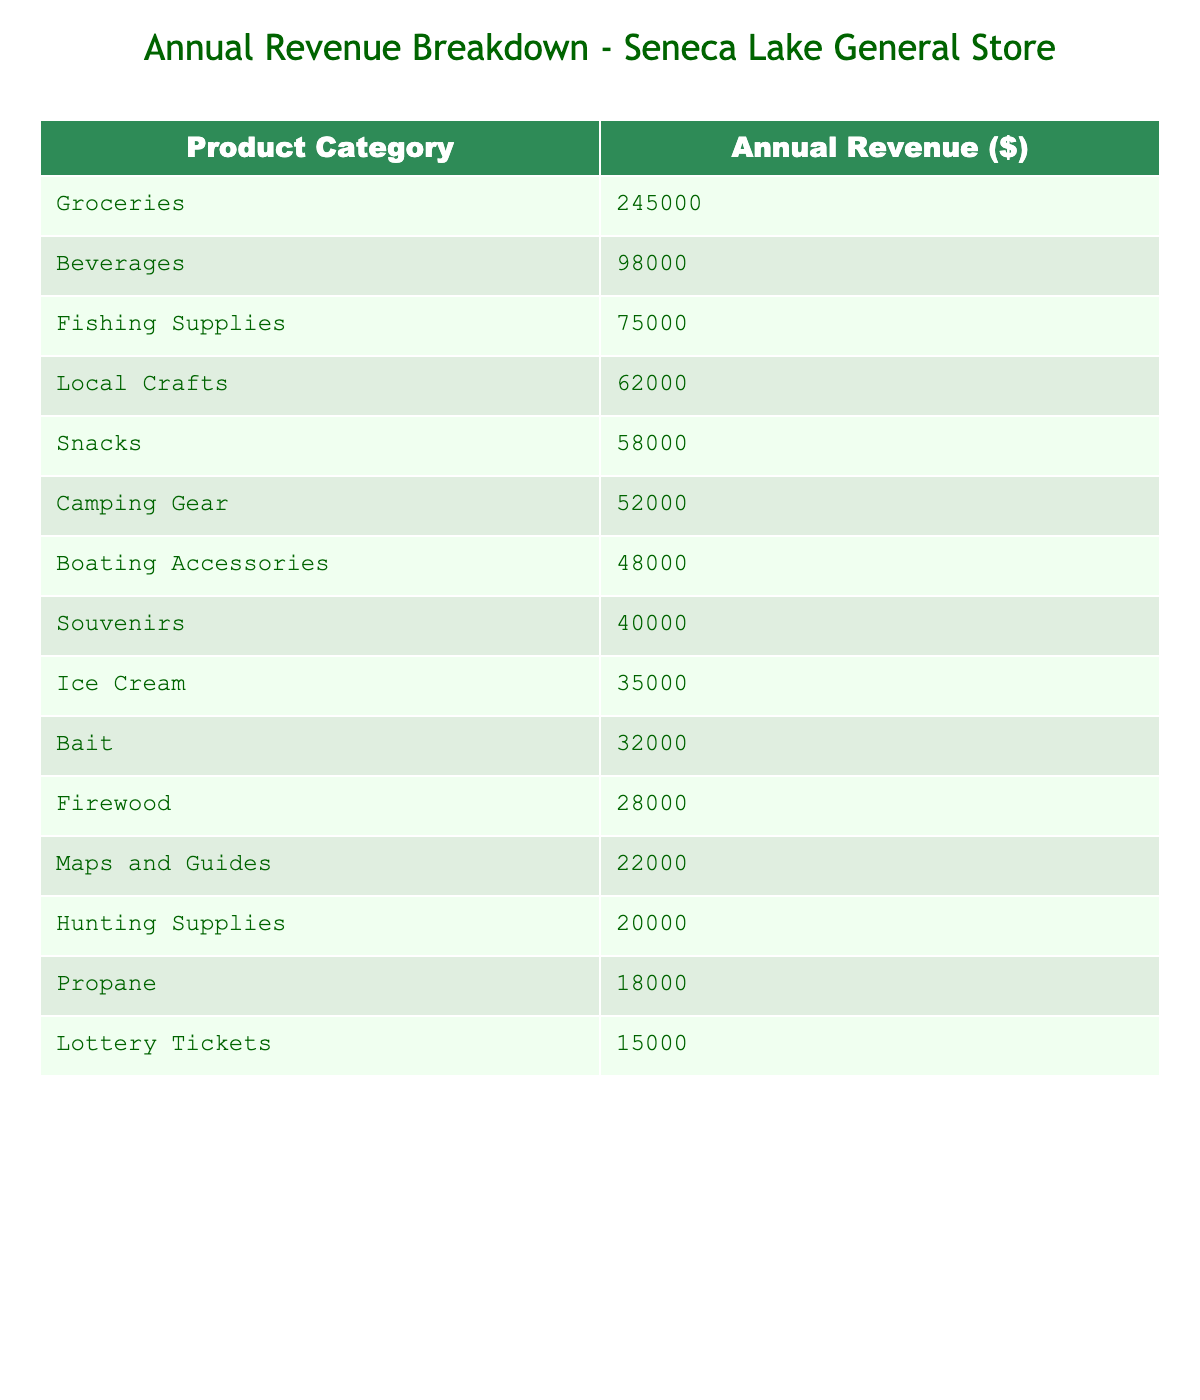What is the annual revenue from groceries? The table lists the annual revenue for groceries as $245,000.
Answer: $245,000 Which product category has the highest annual revenue? By comparing all the values in the table, groceries stands out with the highest value of $245,000.
Answer: Groceries What is the combined annual revenue of beverages and fishing supplies? The annual revenue for beverages is $98,000 and for fishing supplies is $75,000. Adding these two gives $98,000 + $75,000 = $173,000.
Answer: $173,000 Is the annual revenue from local crafts greater than the revenue from snacks? Local crafts generate $62,000, while snacks generate $58,000. Since $62,000 is greater than $58,000, the statement is true.
Answer: Yes What is the total annual revenue for all product categories listed? To find the total, sum all the revenues: $245,000 + $98,000 + $75,000 + $62,000 + $58,000 + $52,000 + $48,000 + $40,000 + $35,000 + $32,000 + $28,000 + $22,000 + $20,000 + $18,000 + $15,000 = $800,000.
Answer: $800,000 How much more revenue does camping gear generate compared to boating accessories? Camping gear generates $52,000, and boating accessories generate $48,000. The difference is $52,000 - $48,000 = $4,000.
Answer: $4,000 What percentage of the total revenue does ice cream contribute? First, find the total revenue, which is $800,000. Ice cream revenue is $35,000. The percentage is ($35,000 / $800,000) * 100 = 4.375%.
Answer: 4.375% Which two product categories combined generate more revenue than fishing supplies? Fishing supplies generate $75,000. Looking at the other categories, beverages ($98,000) alone exceeds that amount. Additionally, groceries and beverages combined ($245,000 + $98,000) significantly exceed fishing supplies, so multiple pairs can work.
Answer: Beverages and any other category (e.g., Local Crafts) What is the average revenue of the top three product categories? The top three categories are groceries ($245,000), beverages ($98,000), and fishing supplies ($75,000). The average is calculated as ($245,000 + $98,000 + $75,000) / 3 = $139,333.33.
Answer: $139,333.33 Does the store generate more revenue from hunting supplies or lottery tickets? Hunting supplies generate $20,000, and lottery tickets generate $15,000. Since $20,000 is greater than $15,000, the statement is true.
Answer: Yes 